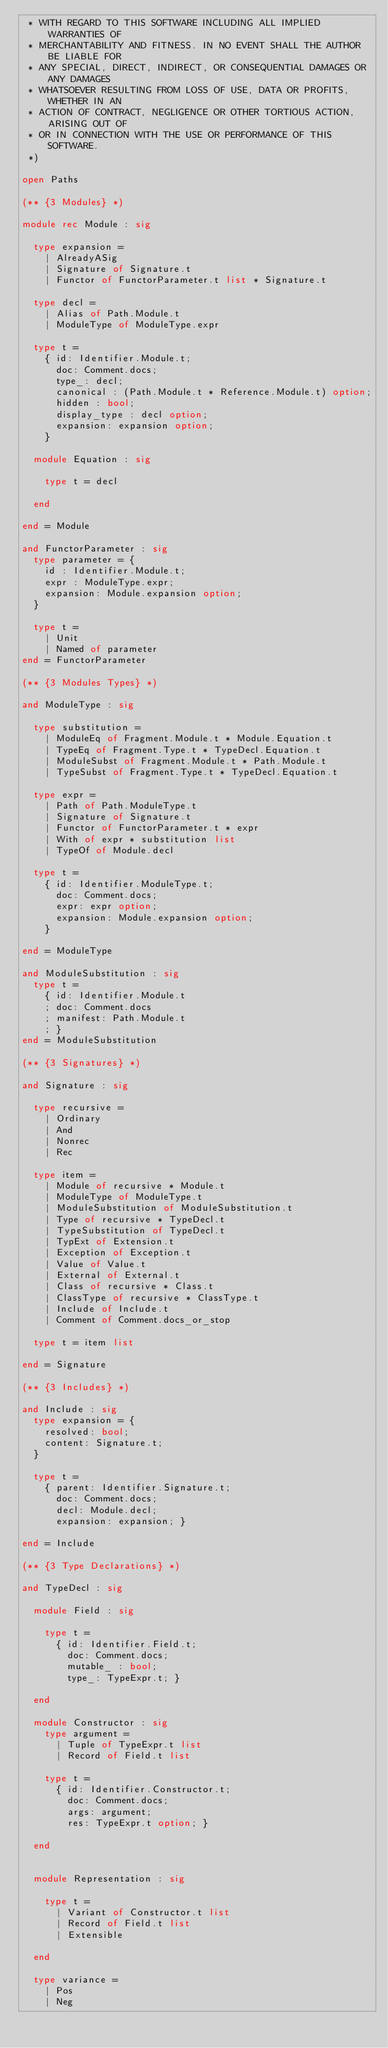<code> <loc_0><loc_0><loc_500><loc_500><_OCaml_> * WITH REGARD TO THIS SOFTWARE INCLUDING ALL IMPLIED WARRANTIES OF
 * MERCHANTABILITY AND FITNESS. IN NO EVENT SHALL THE AUTHOR BE LIABLE FOR
 * ANY SPECIAL, DIRECT, INDIRECT, OR CONSEQUENTIAL DAMAGES OR ANY DAMAGES
 * WHATSOEVER RESULTING FROM LOSS OF USE, DATA OR PROFITS, WHETHER IN AN
 * ACTION OF CONTRACT, NEGLIGENCE OR OTHER TORTIOUS ACTION, ARISING OUT OF
 * OR IN CONNECTION WITH THE USE OR PERFORMANCE OF THIS SOFTWARE.
 *)

open Paths

(** {3 Modules} *)

module rec Module : sig

  type expansion =
    | AlreadyASig
    | Signature of Signature.t
    | Functor of FunctorParameter.t list * Signature.t

  type decl =
    | Alias of Path.Module.t
    | ModuleType of ModuleType.expr

  type t =
    { id: Identifier.Module.t;
      doc: Comment.docs;
      type_: decl;
      canonical : (Path.Module.t * Reference.Module.t) option;
      hidden : bool;
      display_type : decl option;
      expansion: expansion option;
    }

  module Equation : sig

    type t = decl

  end

end = Module

and FunctorParameter : sig
  type parameter = {
    id : Identifier.Module.t;
    expr : ModuleType.expr;
    expansion: Module.expansion option;
  }

  type t = 
    | Unit
    | Named of parameter
end = FunctorParameter

(** {3 Modules Types} *)

and ModuleType : sig

  type substitution =
    | ModuleEq of Fragment.Module.t * Module.Equation.t
    | TypeEq of Fragment.Type.t * TypeDecl.Equation.t
    | ModuleSubst of Fragment.Module.t * Path.Module.t
    | TypeSubst of Fragment.Type.t * TypeDecl.Equation.t

  type expr =
    | Path of Path.ModuleType.t
    | Signature of Signature.t
    | Functor of FunctorParameter.t * expr
    | With of expr * substitution list
    | TypeOf of Module.decl

  type t =
    { id: Identifier.ModuleType.t;
      doc: Comment.docs;
      expr: expr option;
      expansion: Module.expansion option;
    }

end = ModuleType

and ModuleSubstitution : sig
  type t =
    { id: Identifier.Module.t
    ; doc: Comment.docs
    ; manifest: Path.Module.t
    ; }
end = ModuleSubstitution

(** {3 Signatures} *)

and Signature : sig

  type recursive =
    | Ordinary
    | And
    | Nonrec
    | Rec

  type item =
    | Module of recursive * Module.t
    | ModuleType of ModuleType.t
    | ModuleSubstitution of ModuleSubstitution.t
    | Type of recursive * TypeDecl.t
    | TypeSubstitution of TypeDecl.t
    | TypExt of Extension.t
    | Exception of Exception.t
    | Value of Value.t
    | External of External.t
    | Class of recursive * Class.t
    | ClassType of recursive * ClassType.t
    | Include of Include.t
    | Comment of Comment.docs_or_stop

  type t = item list

end = Signature

(** {3 Includes} *)

and Include : sig
  type expansion = {
    resolved: bool;
    content: Signature.t;
  }

  type t =
    { parent: Identifier.Signature.t;
      doc: Comment.docs;
      decl: Module.decl;
      expansion: expansion; }

end = Include

(** {3 Type Declarations} *)

and TypeDecl : sig

  module Field : sig

    type t =
      { id: Identifier.Field.t;
        doc: Comment.docs;
        mutable_ : bool;
        type_: TypeExpr.t; }

  end

  module Constructor : sig
    type argument =
      | Tuple of TypeExpr.t list
      | Record of Field.t list

    type t =
      { id: Identifier.Constructor.t;
        doc: Comment.docs;
        args: argument;
        res: TypeExpr.t option; }

  end


  module Representation : sig

    type t =
      | Variant of Constructor.t list
      | Record of Field.t list
      | Extensible

  end

  type variance =
    | Pos
    | Neg
</code> 